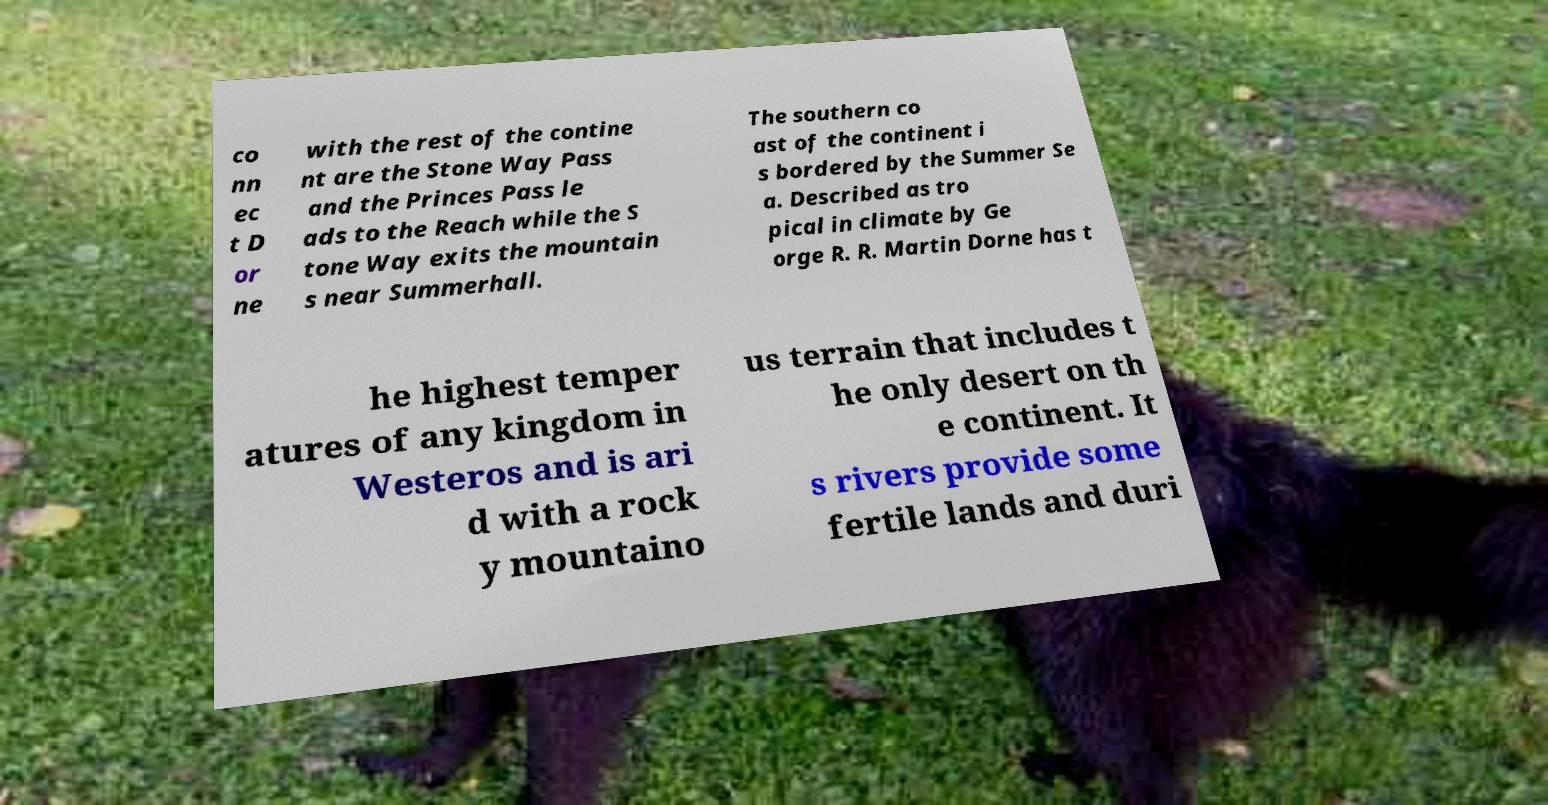Please read and relay the text visible in this image. What does it say? co nn ec t D or ne with the rest of the contine nt are the Stone Way Pass and the Princes Pass le ads to the Reach while the S tone Way exits the mountain s near Summerhall. The southern co ast of the continent i s bordered by the Summer Se a. Described as tro pical in climate by Ge orge R. R. Martin Dorne has t he highest temper atures of any kingdom in Westeros and is ari d with a rock y mountaino us terrain that includes t he only desert on th e continent. It s rivers provide some fertile lands and duri 